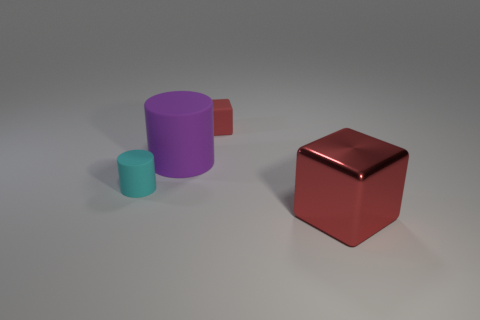Add 3 small brown matte cylinders. How many objects exist? 7 Subtract 2 cylinders. How many cylinders are left? 0 Subtract all cyan cylinders. How many cylinders are left? 1 Subtract 0 red spheres. How many objects are left? 4 Subtract all green cylinders. Subtract all red balls. How many cylinders are left? 2 Subtract all blue balls. How many cyan cylinders are left? 1 Subtract all blue shiny spheres. Subtract all small things. How many objects are left? 2 Add 4 cyan matte cylinders. How many cyan matte cylinders are left? 5 Add 3 small cubes. How many small cubes exist? 4 